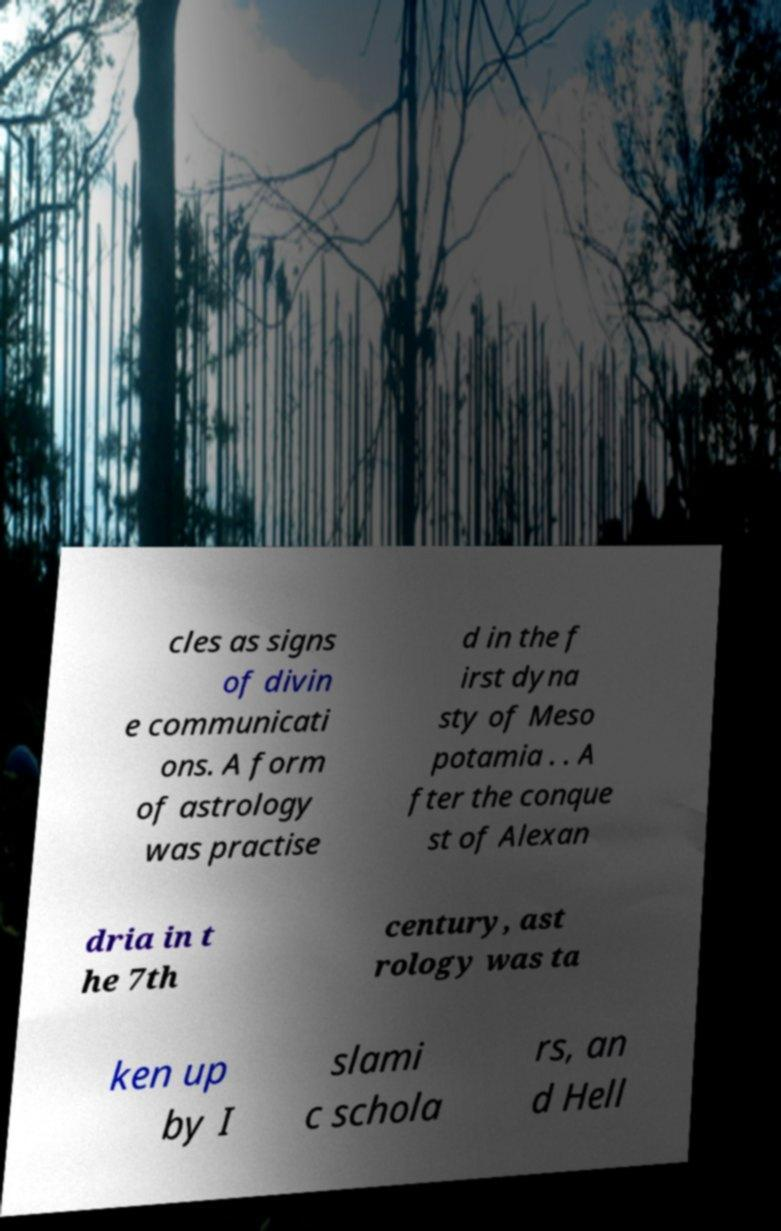Please read and relay the text visible in this image. What does it say? cles as signs of divin e communicati ons. A form of astrology was practise d in the f irst dyna sty of Meso potamia . . A fter the conque st of Alexan dria in t he 7th century, ast rology was ta ken up by I slami c schola rs, an d Hell 